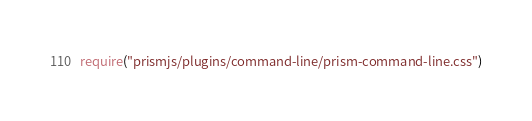<code> <loc_0><loc_0><loc_500><loc_500><_JavaScript_>require("prismjs/plugins/command-line/prism-command-line.css")
</code> 